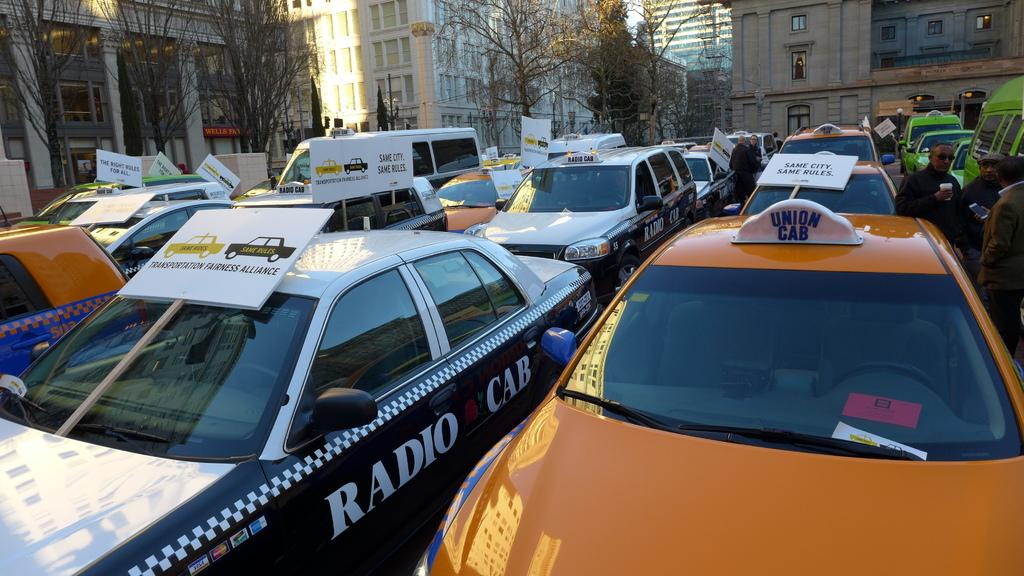<image>
Provide a brief description of the given image. A Radio Cab is next to an orange Union Cab on a busy street. 